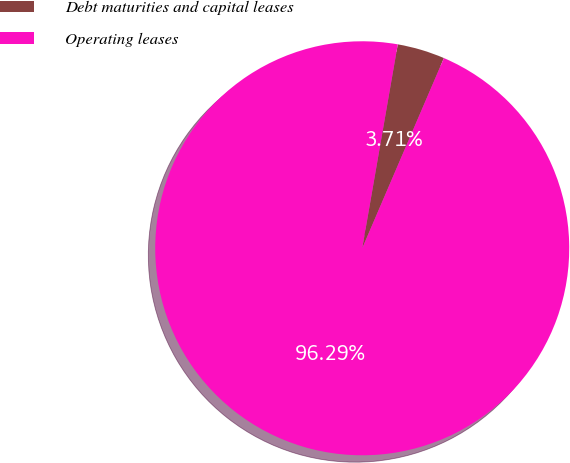Convert chart. <chart><loc_0><loc_0><loc_500><loc_500><pie_chart><fcel>Debt maturities and capital leases<fcel>Operating leases<nl><fcel>3.71%<fcel>96.29%<nl></chart> 